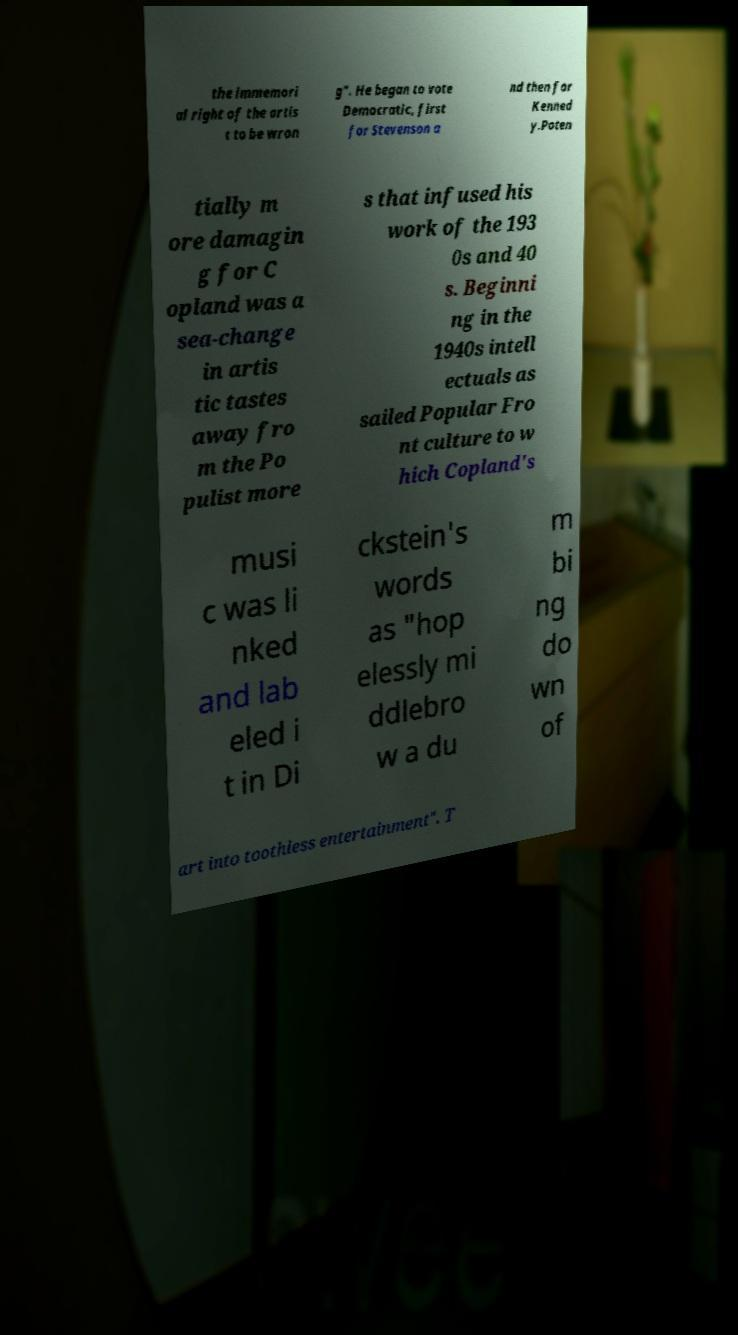For documentation purposes, I need the text within this image transcribed. Could you provide that? the immemori al right of the artis t to be wron g". He began to vote Democratic, first for Stevenson a nd then for Kenned y.Poten tially m ore damagin g for C opland was a sea-change in artis tic tastes away fro m the Po pulist more s that infused his work of the 193 0s and 40 s. Beginni ng in the 1940s intell ectuals as sailed Popular Fro nt culture to w hich Copland's musi c was li nked and lab eled i t in Di ckstein's words as "hop elessly mi ddlebro w a du m bi ng do wn of art into toothless entertainment". T 